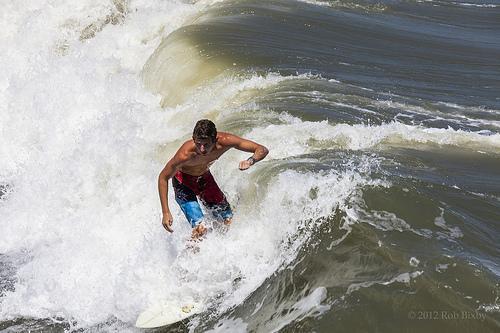How many people are seen?
Give a very brief answer. 1. 